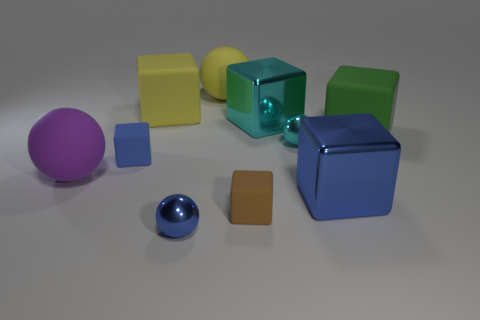Subtract all brown cylinders. How many blue blocks are left? 2 Subtract all big cubes. How many cubes are left? 2 Subtract all cyan cubes. How many cubes are left? 5 Subtract 3 blocks. How many blocks are left? 3 Subtract all cubes. How many objects are left? 4 Subtract all red blocks. Subtract all green cylinders. How many blocks are left? 6 Subtract 1 blue blocks. How many objects are left? 9 Subtract all small cyan cylinders. Subtract all purple matte spheres. How many objects are left? 9 Add 3 big green objects. How many big green objects are left? 4 Add 4 big blue blocks. How many big blue blocks exist? 5 